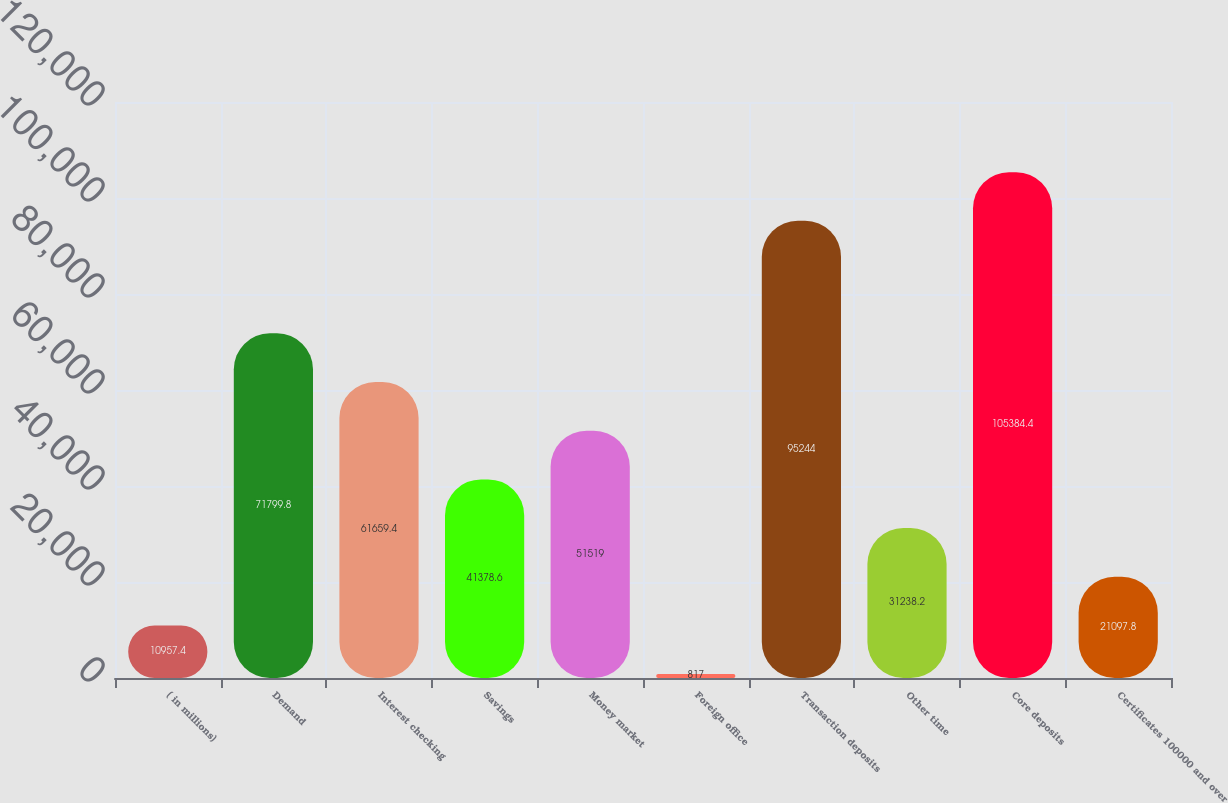Convert chart. <chart><loc_0><loc_0><loc_500><loc_500><bar_chart><fcel>( in millions)<fcel>Demand<fcel>Interest checking<fcel>Savings<fcel>Money market<fcel>Foreign office<fcel>Transaction deposits<fcel>Other time<fcel>Core deposits<fcel>Certificates 100000 and over<nl><fcel>10957.4<fcel>71799.8<fcel>61659.4<fcel>41378.6<fcel>51519<fcel>817<fcel>95244<fcel>31238.2<fcel>105384<fcel>21097.8<nl></chart> 